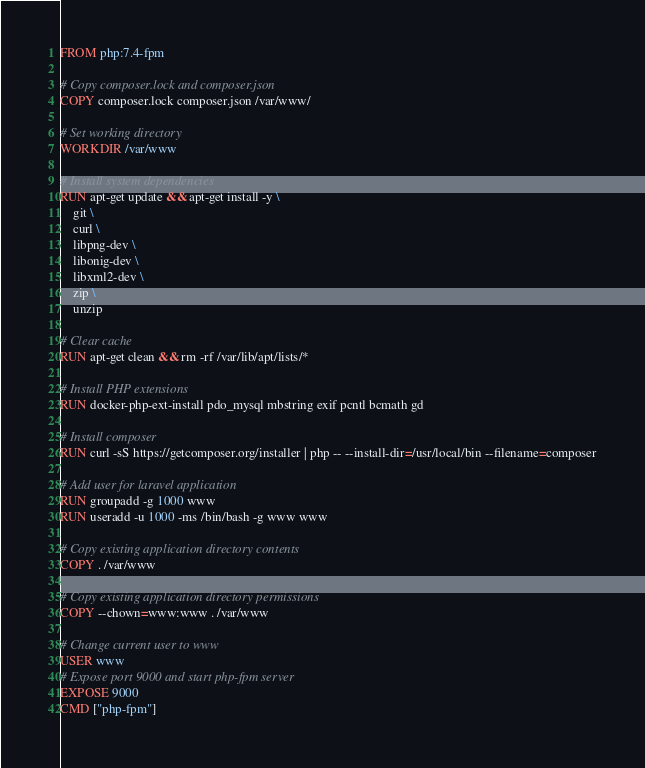Convert code to text. <code><loc_0><loc_0><loc_500><loc_500><_Dockerfile_>FROM php:7.4-fpm

# Copy composer.lock and composer.json
COPY composer.lock composer.json /var/www/

# Set working directory
WORKDIR /var/www

# Install system dependencies
RUN apt-get update && apt-get install -y \
    git \
    curl \
    libpng-dev \
    libonig-dev \
    libxml2-dev \
    zip \
    unzip

# Clear cache
RUN apt-get clean && rm -rf /var/lib/apt/lists/*

# Install PHP extensions
RUN docker-php-ext-install pdo_mysql mbstring exif pcntl bcmath gd

# Install composer
RUN curl -sS https://getcomposer.org/installer | php -- --install-dir=/usr/local/bin --filename=composer

# Add user for laravel application
RUN groupadd -g 1000 www
RUN useradd -u 1000 -ms /bin/bash -g www www

# Copy existing application directory contents
COPY . /var/www

# Copy existing application directory permissions
COPY --chown=www:www . /var/www

# Change current user to www
USER www
# Expose port 9000 and start php-fpm server
EXPOSE 9000
CMD ["php-fpm"]
</code> 